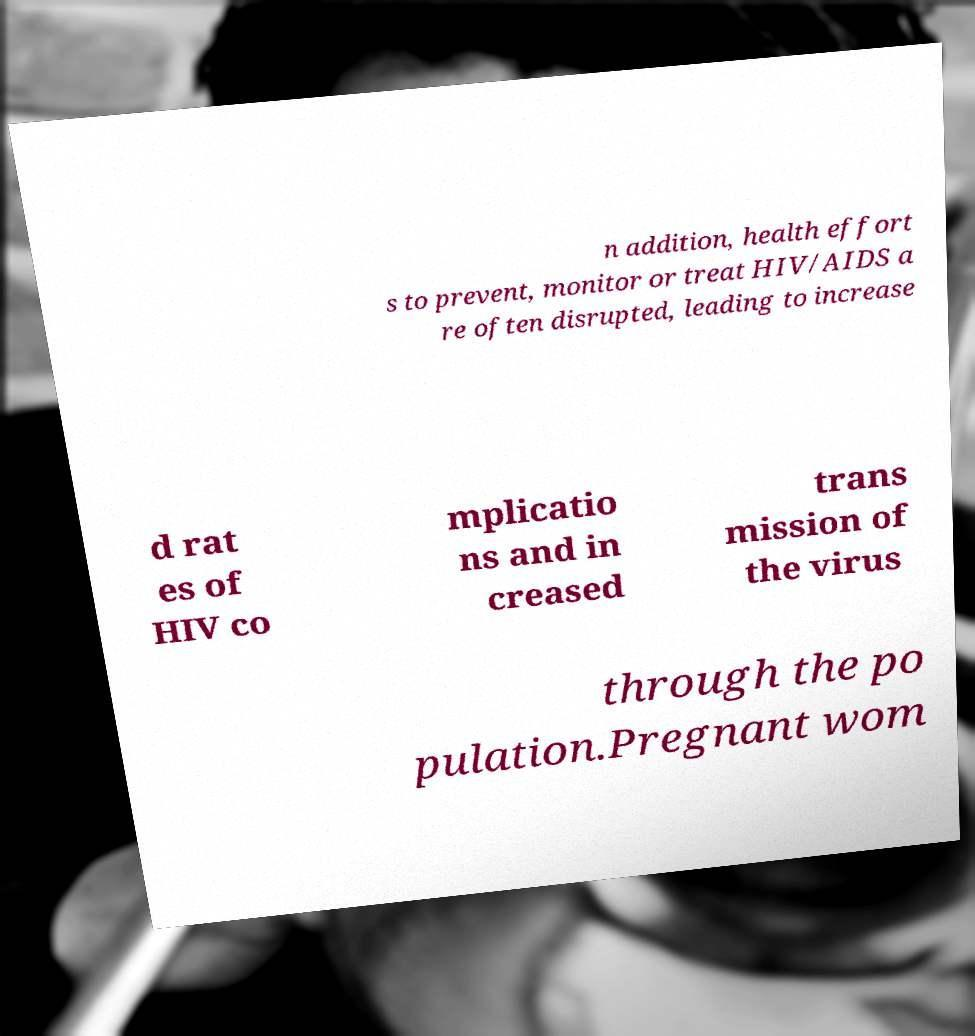Can you accurately transcribe the text from the provided image for me? n addition, health effort s to prevent, monitor or treat HIV/AIDS a re often disrupted, leading to increase d rat es of HIV co mplicatio ns and in creased trans mission of the virus through the po pulation.Pregnant wom 